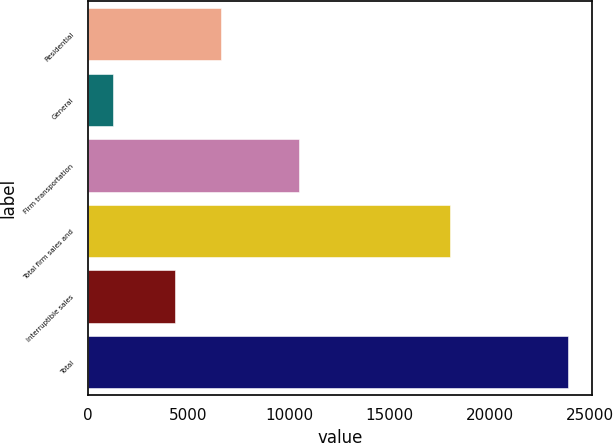<chart> <loc_0><loc_0><loc_500><loc_500><bar_chart><fcel>Residential<fcel>General<fcel>Firm transportation<fcel>Total firm sales and<fcel>Interruptible sales<fcel>Total<nl><fcel>6591.3<fcel>1248<fcel>10505<fcel>18044<fcel>4326<fcel>23901<nl></chart> 